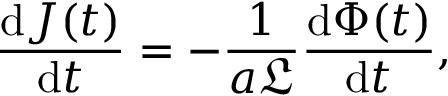Convert formula to latex. <formula><loc_0><loc_0><loc_500><loc_500>\frac { d J ( t ) } { d t } = - \frac { 1 } { a \mathfrak { L } } \frac { d \Phi ( t ) } { d t } ,</formula> 